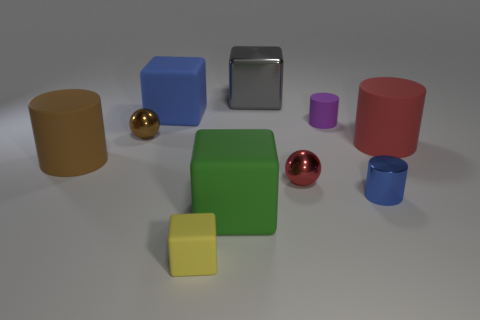Subtract all gray cubes. How many cubes are left? 3 Subtract all brown balls. How many balls are left? 1 Subtract 2 blocks. How many blocks are left? 2 Subtract all cylinders. How many objects are left? 6 Subtract all gray blocks. How many cyan cylinders are left? 0 Subtract all purple matte cylinders. Subtract all green matte things. How many objects are left? 8 Add 6 rubber cubes. How many rubber cubes are left? 9 Add 4 small cyan matte objects. How many small cyan matte objects exist? 4 Subtract 1 yellow blocks. How many objects are left? 9 Subtract all cyan blocks. Subtract all blue cylinders. How many blocks are left? 4 